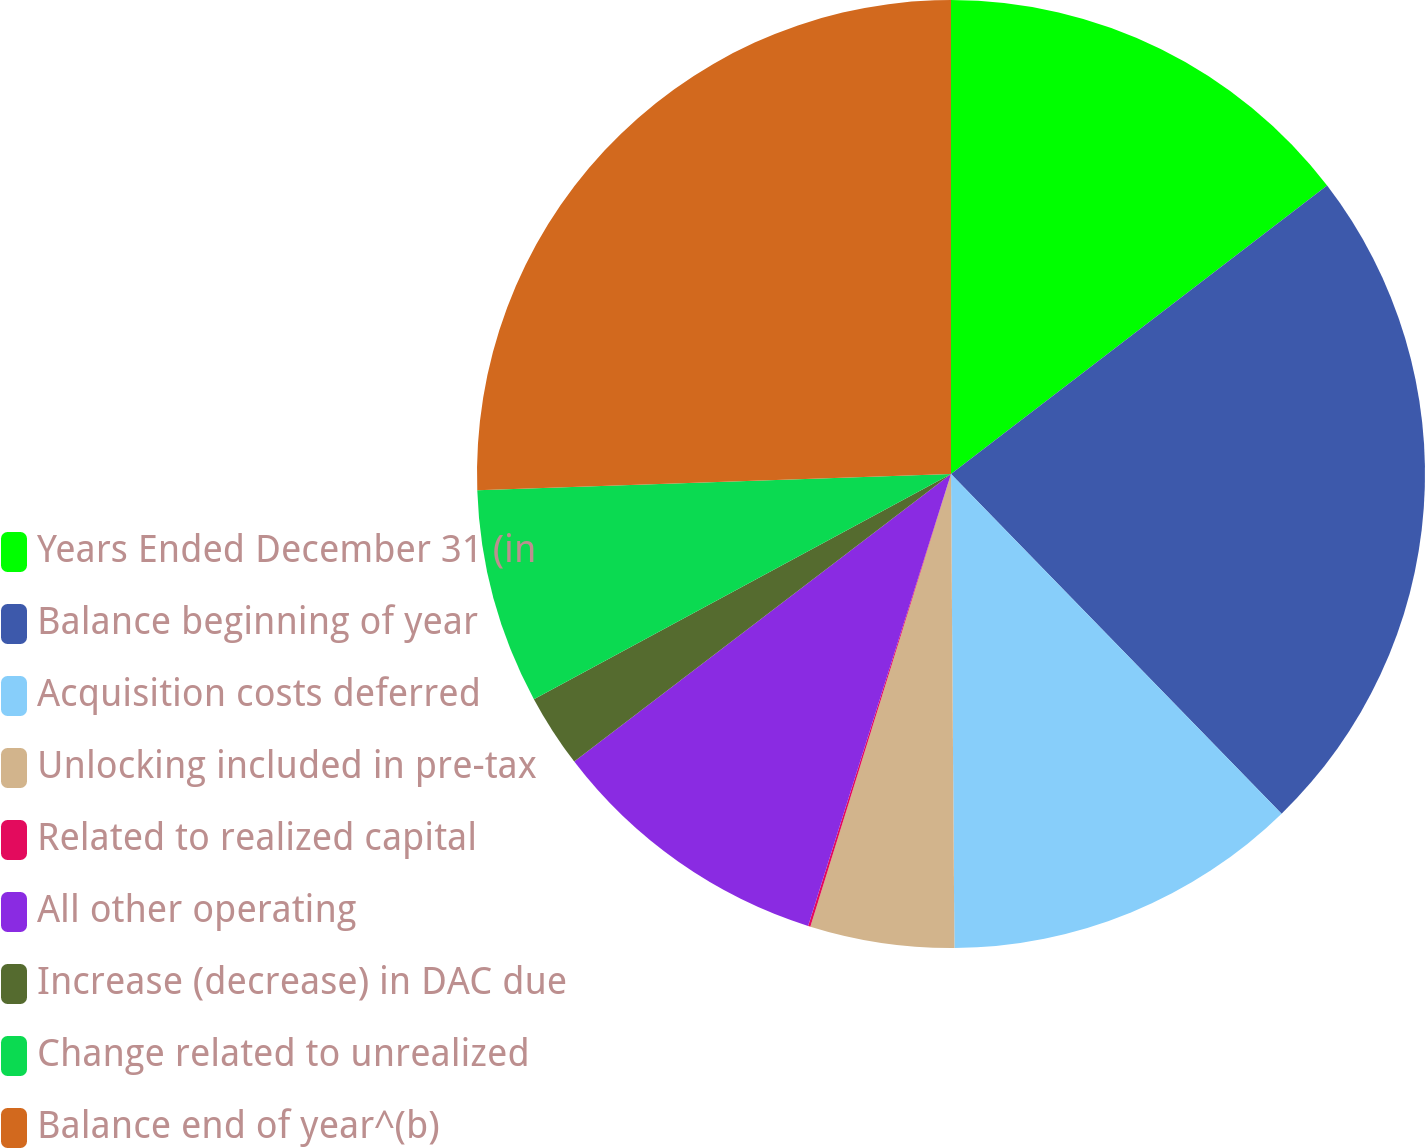Convert chart to OTSL. <chart><loc_0><loc_0><loc_500><loc_500><pie_chart><fcel>Years Ended December 31 (in<fcel>Balance beginning of year<fcel>Acquisition costs deferred<fcel>Unlocking included in pre-tax<fcel>Related to realized capital<fcel>All other operating<fcel>Increase (decrease) in DAC due<fcel>Change related to unrealized<fcel>Balance end of year^(b)<nl><fcel>14.59%<fcel>23.13%<fcel>12.17%<fcel>4.91%<fcel>0.08%<fcel>9.75%<fcel>2.5%<fcel>7.33%<fcel>25.55%<nl></chart> 